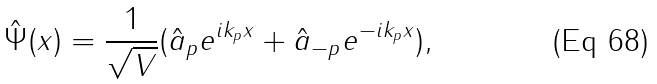<formula> <loc_0><loc_0><loc_500><loc_500>\hat { \Psi } ( x ) = \frac { 1 } { \sqrt { V } } ( \hat { a } _ { p } e ^ { i k _ { p } x } + \hat { a } _ { - p } e ^ { - i k _ { p } x } ) ,</formula> 